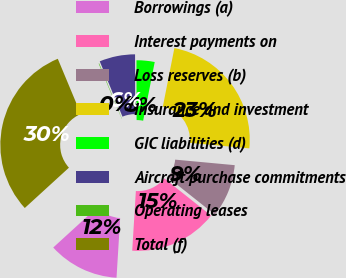Convert chart. <chart><loc_0><loc_0><loc_500><loc_500><pie_chart><fcel>Borrowings (a)<fcel>Interest payments on<fcel>Loss reserves (b)<fcel>Insurance and investment<fcel>GIC liabilities (d)<fcel>Aircraft purchase commitments<fcel>Operating leases<fcel>Total (f)<nl><fcel>12.25%<fcel>15.29%<fcel>9.21%<fcel>23.38%<fcel>3.13%<fcel>6.17%<fcel>0.09%<fcel>30.49%<nl></chart> 